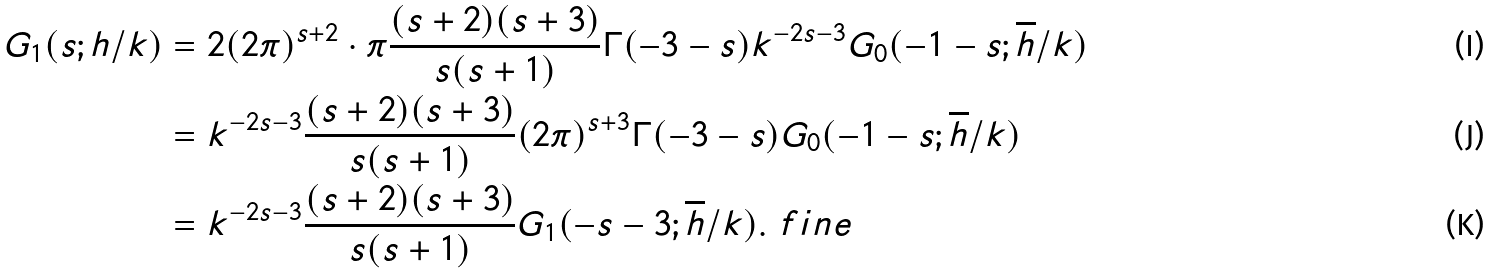Convert formula to latex. <formula><loc_0><loc_0><loc_500><loc_500>G _ { 1 } ( s ; h / k ) & = 2 ( 2 \pi ) ^ { s + 2 } \cdot \pi \frac { ( s + 2 ) ( s + 3 ) } { s ( s + 1 ) } \Gamma ( - 3 - s ) k ^ { - 2 s - 3 } G _ { 0 } ( - 1 - s ; \overline { h } / k ) \\ & = k ^ { - 2 s - 3 } \frac { ( s + 2 ) ( s + 3 ) } { s ( s + 1 ) } ( 2 \pi ) ^ { s + 3 } \Gamma ( - 3 - s ) G _ { 0 } ( - 1 - s ; \overline { h } / k ) \\ & = k ^ { - 2 s - 3 } \frac { ( s + 2 ) ( s + 3 ) } { s ( s + 1 ) } G _ { 1 } ( - s - 3 ; \overline { h } / k ) . \ f i n e</formula> 